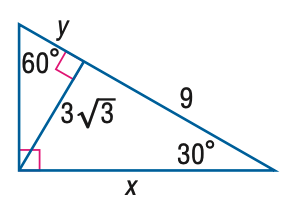Question: Find x.
Choices:
A. 3 \sqrt { 6 }
B. 9
C. 6 \sqrt { 3 }
D. 18
Answer with the letter. Answer: C Question: Find y.
Choices:
A. 3
B. 3 \sqrt { 3 }
C. 9
D. 6 \sqrt { 3 }
Answer with the letter. Answer: A 